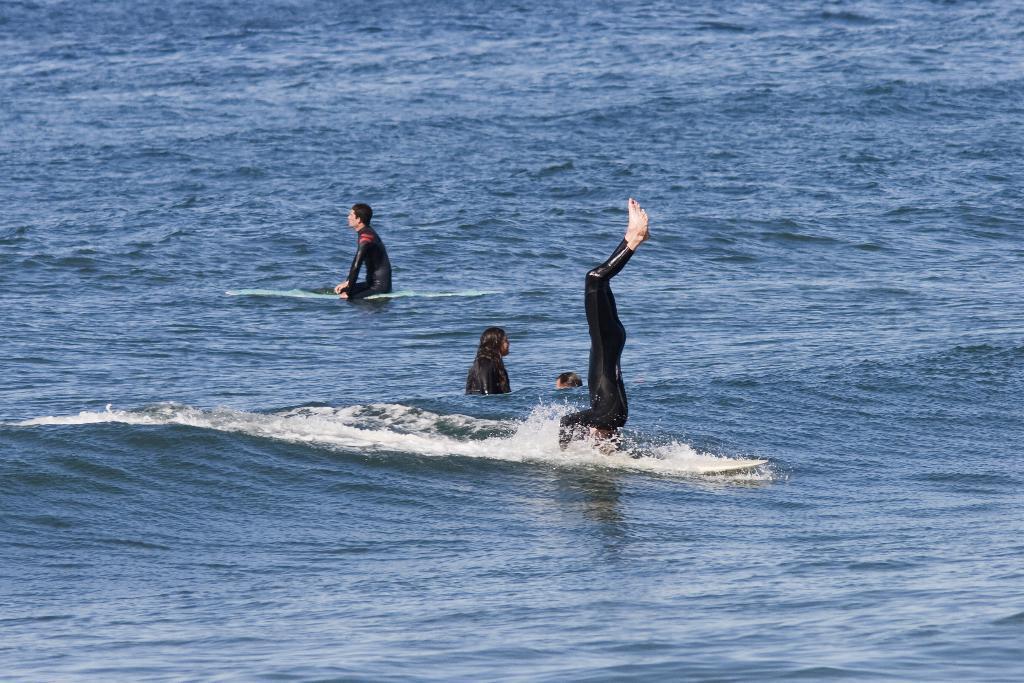Can you describe this image briefly? We can see people and water. 